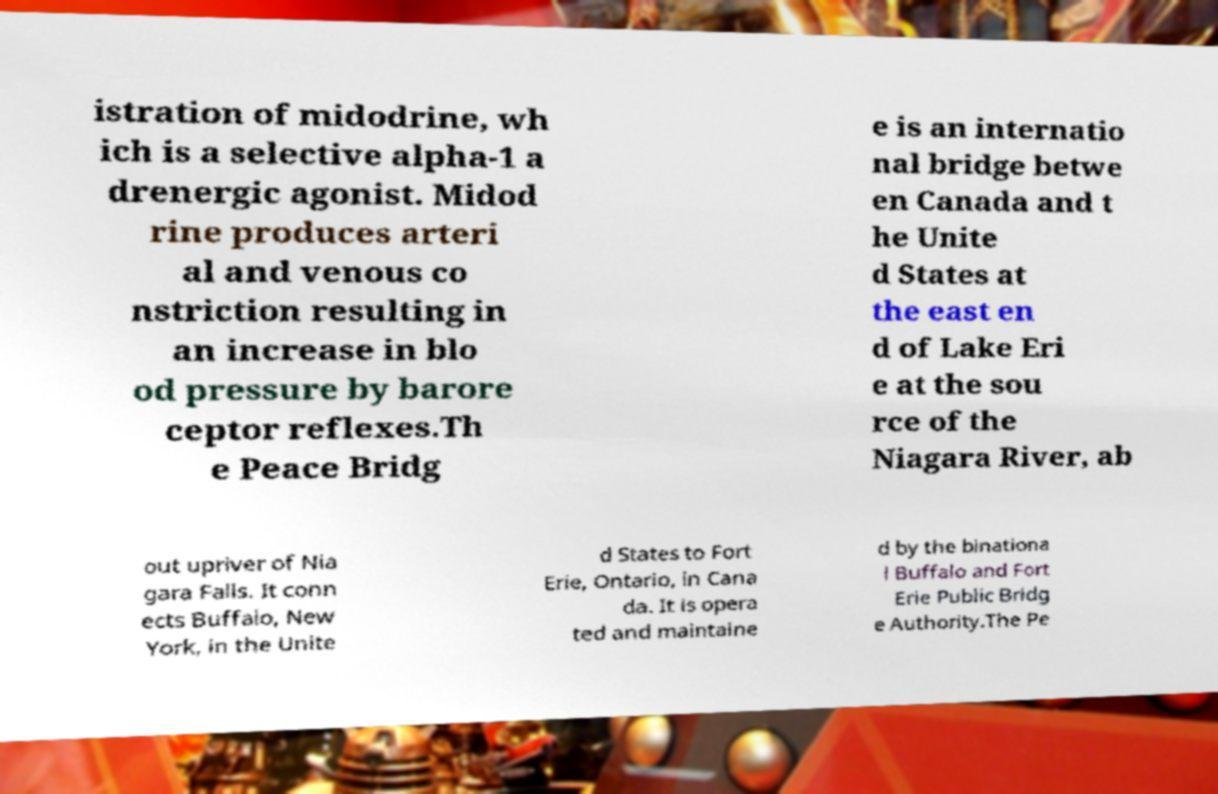Could you extract and type out the text from this image? istration of midodrine, wh ich is a selective alpha-1 a drenergic agonist. Midod rine produces arteri al and venous co nstriction resulting in an increase in blo od pressure by barore ceptor reflexes.Th e Peace Bridg e is an internatio nal bridge betwe en Canada and t he Unite d States at the east en d of Lake Eri e at the sou rce of the Niagara River, ab out upriver of Nia gara Falls. It conn ects Buffalo, New York, in the Unite d States to Fort Erie, Ontario, in Cana da. It is opera ted and maintaine d by the binationa l Buffalo and Fort Erie Public Bridg e Authority.The Pe 